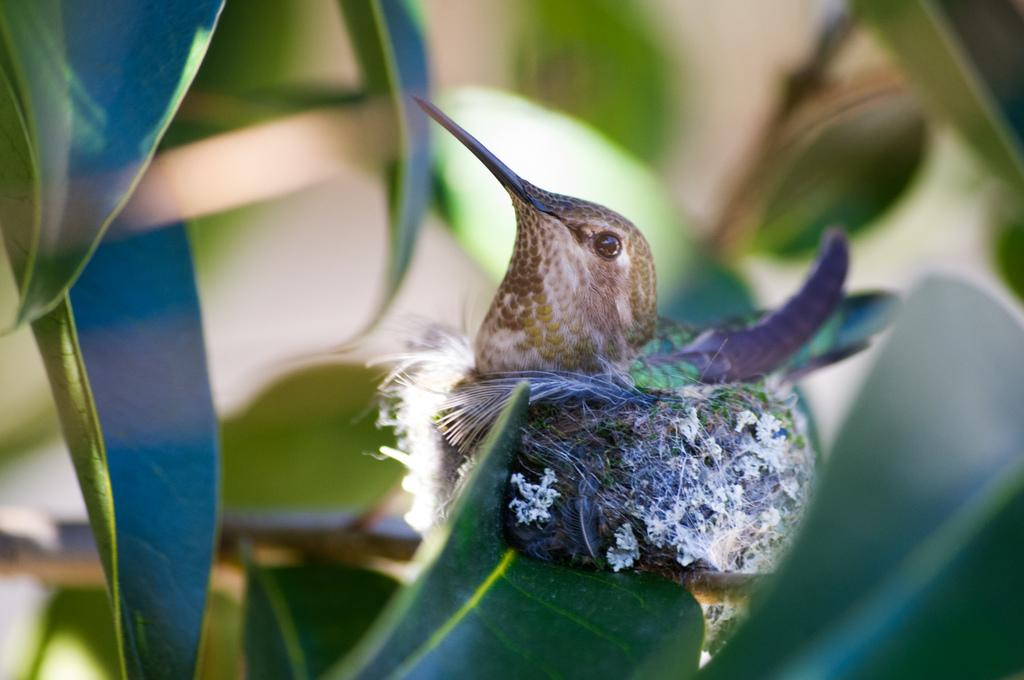What type of animal is in the image? There is a bird in the image. What colors can be seen on the bird? The bird has brown and violet colors. Where is the bird located in the image? The bird is on a leaf of a plant. How would you describe the background of the image? The background of the image is blurred. What type of feeling does the bird express in the image? The image does not convey any specific feelings or emotions of the bird, as it is a still image. 